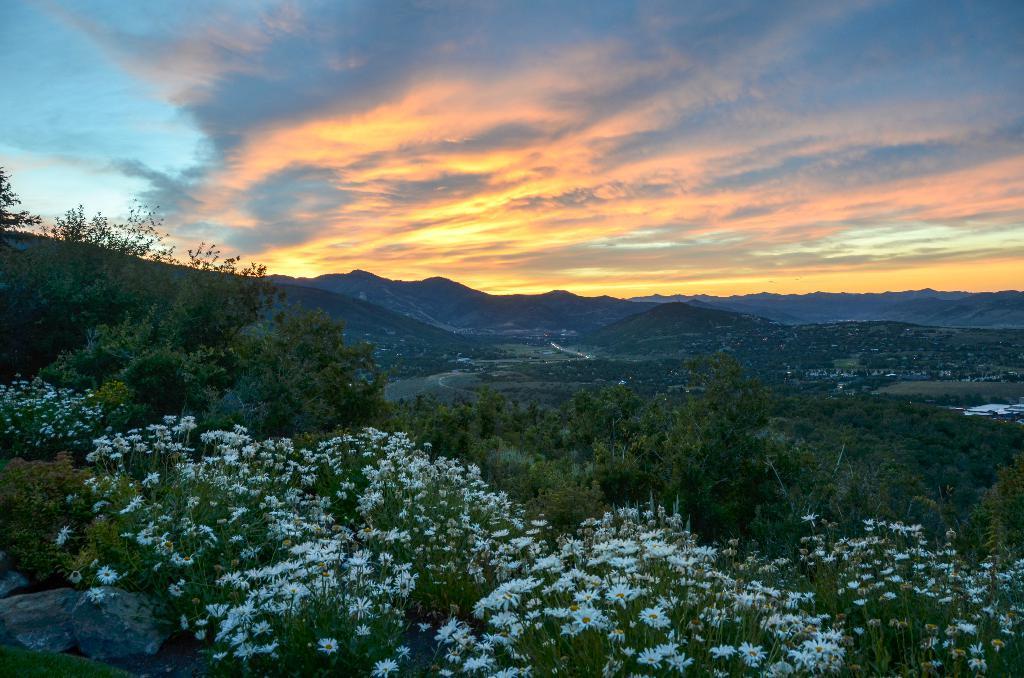Describe this image in one or two sentences. Here at the bottom we can see plants with flowers. In the background there are trees,grass,houses,mountains and clouds in the sky. 